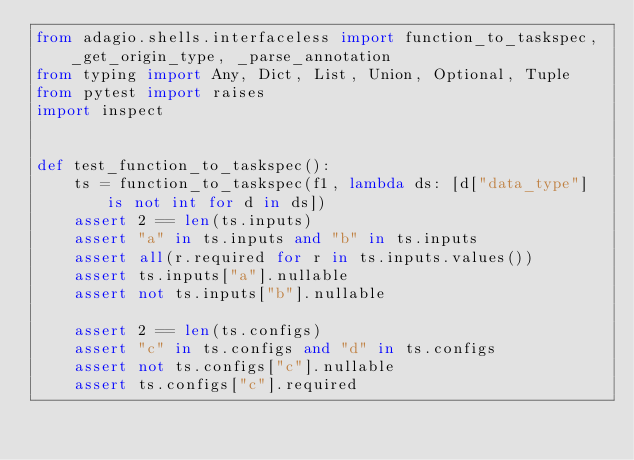<code> <loc_0><loc_0><loc_500><loc_500><_Python_>from adagio.shells.interfaceless import function_to_taskspec, _get_origin_type, _parse_annotation
from typing import Any, Dict, List, Union, Optional, Tuple
from pytest import raises
import inspect


def test_function_to_taskspec():
    ts = function_to_taskspec(f1, lambda ds: [d["data_type"] is not int for d in ds])
    assert 2 == len(ts.inputs)
    assert "a" in ts.inputs and "b" in ts.inputs
    assert all(r.required for r in ts.inputs.values())
    assert ts.inputs["a"].nullable
    assert not ts.inputs["b"].nullable

    assert 2 == len(ts.configs)
    assert "c" in ts.configs and "d" in ts.configs
    assert not ts.configs["c"].nullable
    assert ts.configs["c"].required</code> 